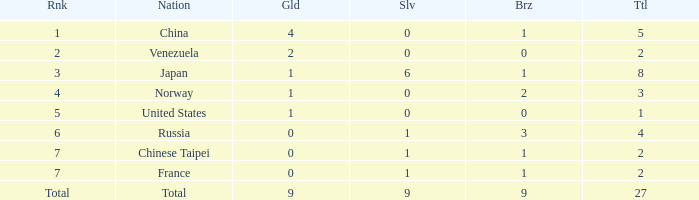Could you parse the entire table? {'header': ['Rnk', 'Nation', 'Gld', 'Slv', 'Brz', 'Ttl'], 'rows': [['1', 'China', '4', '0', '1', '5'], ['2', 'Venezuela', '2', '0', '0', '2'], ['3', 'Japan', '1', '6', '1', '8'], ['4', 'Norway', '1', '0', '2', '3'], ['5', 'United States', '1', '0', '0', '1'], ['6', 'Russia', '0', '1', '3', '4'], ['7', 'Chinese Taipei', '0', '1', '1', '2'], ['7', 'France', '0', '1', '1', '2'], ['Total', 'Total', '9', '9', '9', '27']]} What is the average Bronze for rank 3 and total is more than 8? None. 